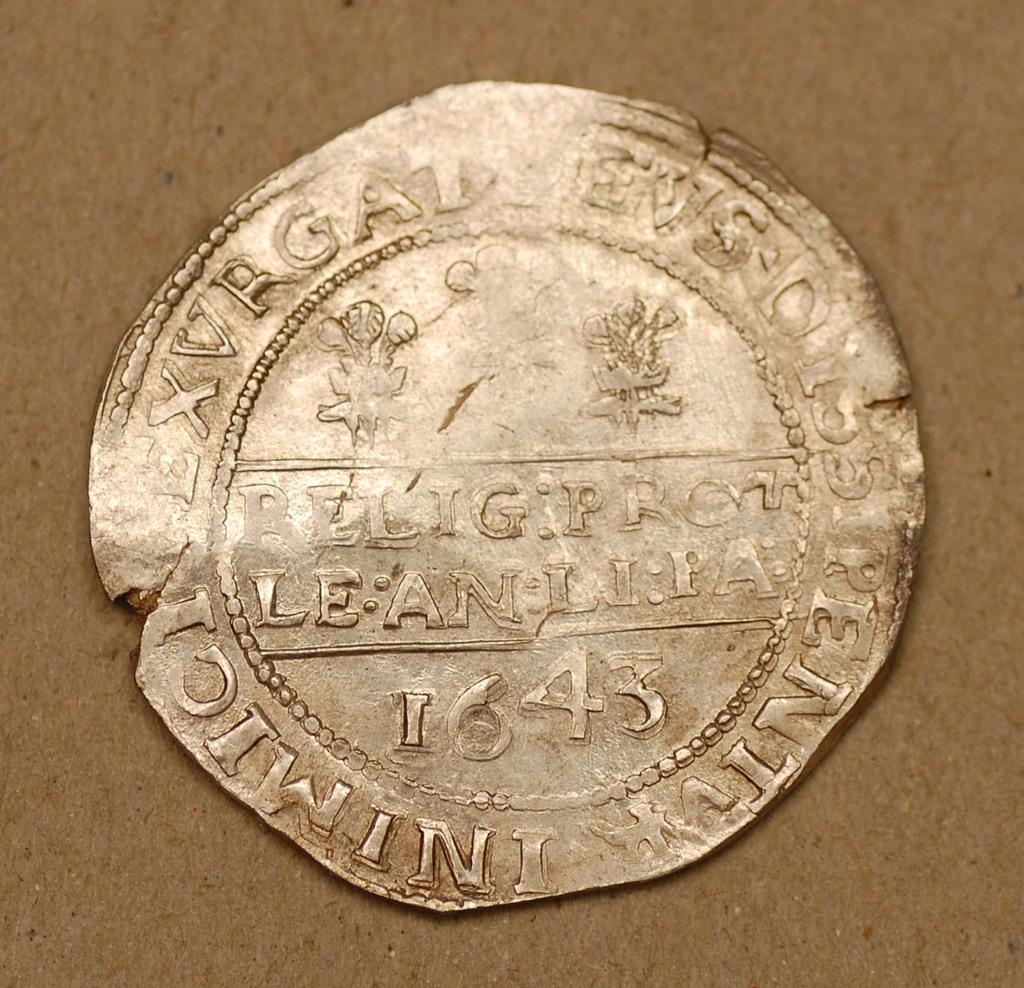What object is the main focus of the image? The main focus of the image is a coin. What can be found on the surface of the coin? The coin has numbers and letters engraved on it. What type of twig is being used to apply lipstick in the image? There is no twig or lipstick present in the image; it only features a coin with numbers and letters engraved on it. 